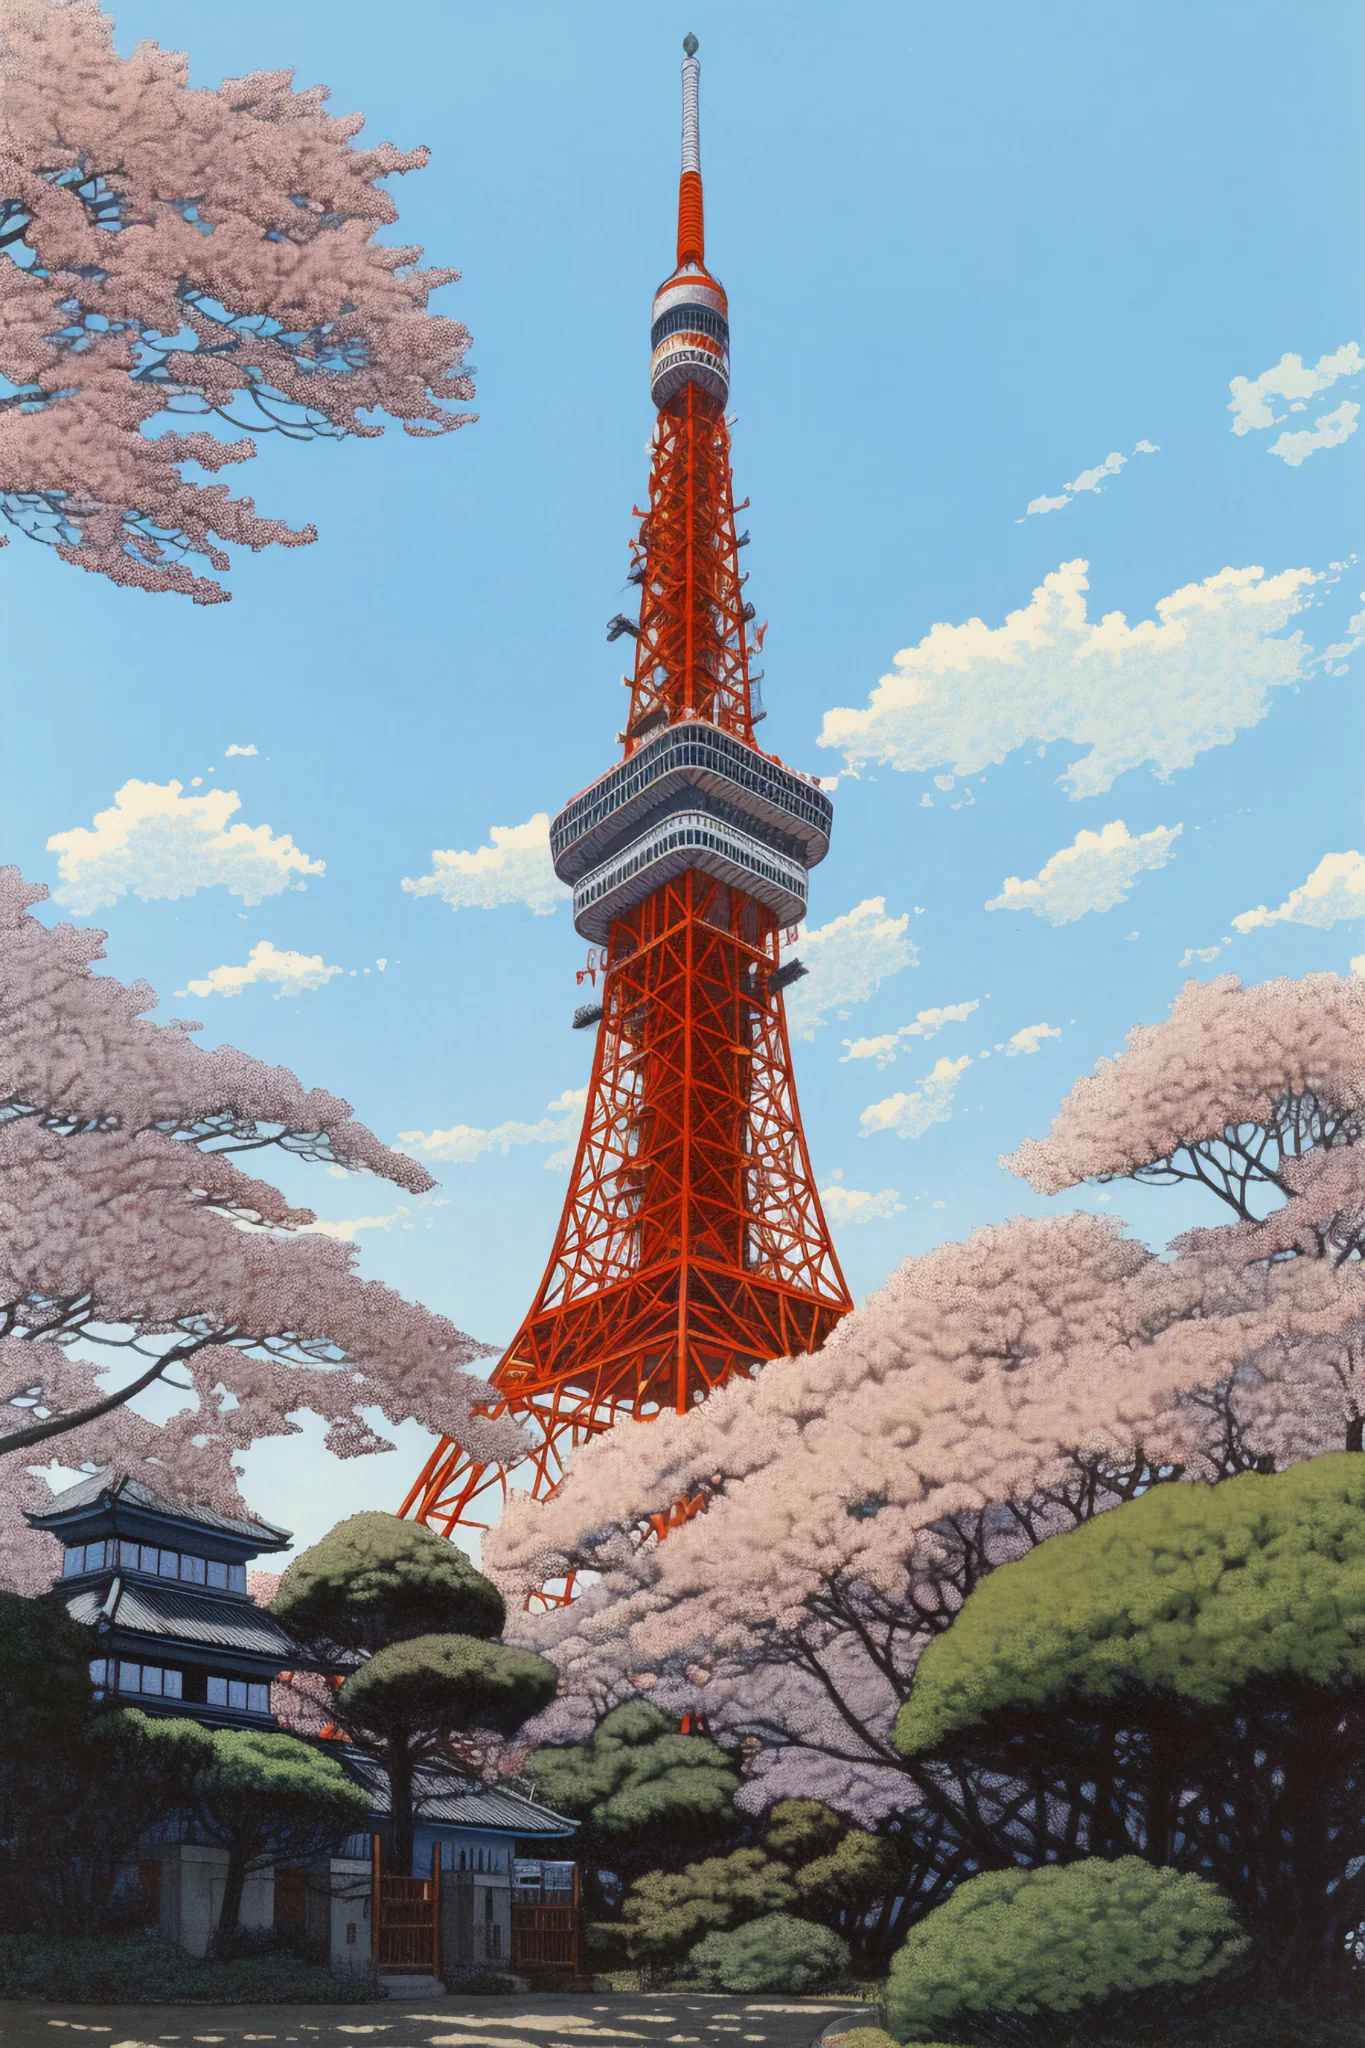Can you describe a scenario where this picture could be part of a historical event? This image could represent a modern-day commemoration of Japan's remarkable post-war reconstruction era, a pivotal period when the Tokyo Tower was constructed in 1958. Imagine an annual festival held in April during the cherry blossom season, where citizens gather around Tokyo Tower to celebrate the nation's resilience and progress. The blooming sakura would symbolize new beginnings and the delicate beauty of peace, while the towering structure stands as a beacon of technological achievement and hope. 